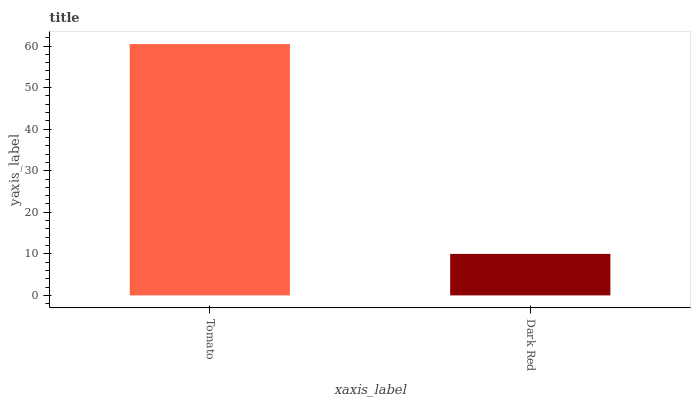Is Dark Red the minimum?
Answer yes or no. Yes. Is Tomato the maximum?
Answer yes or no. Yes. Is Dark Red the maximum?
Answer yes or no. No. Is Tomato greater than Dark Red?
Answer yes or no. Yes. Is Dark Red less than Tomato?
Answer yes or no. Yes. Is Dark Red greater than Tomato?
Answer yes or no. No. Is Tomato less than Dark Red?
Answer yes or no. No. Is Tomato the high median?
Answer yes or no. Yes. Is Dark Red the low median?
Answer yes or no. Yes. Is Dark Red the high median?
Answer yes or no. No. Is Tomato the low median?
Answer yes or no. No. 